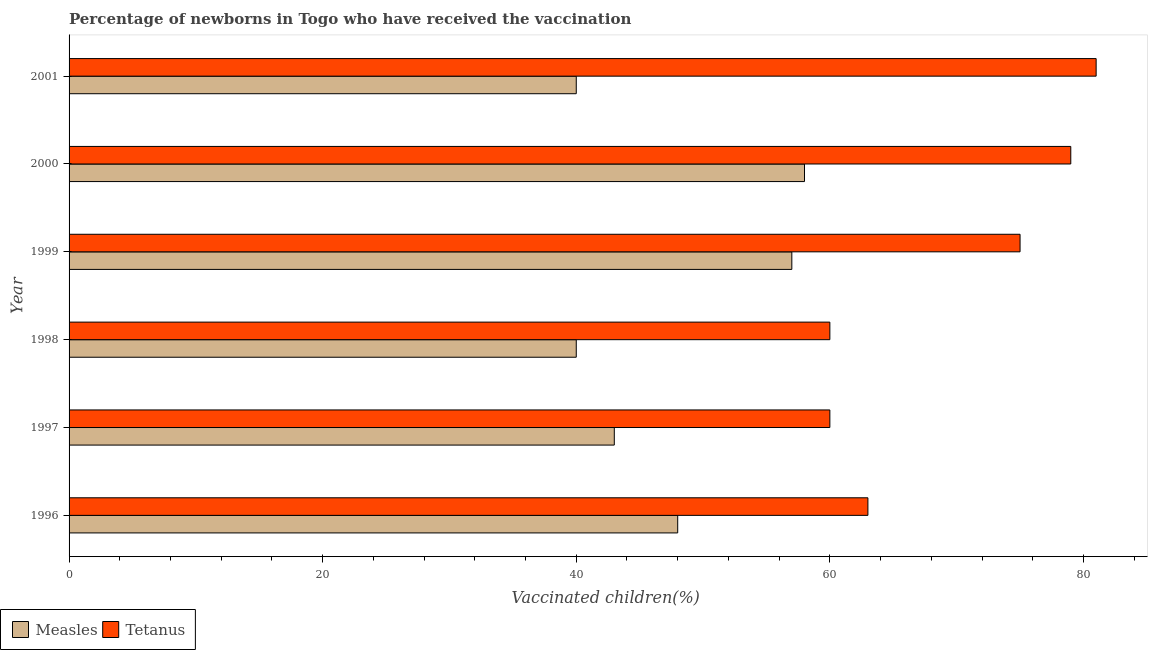How many different coloured bars are there?
Offer a terse response. 2. How many groups of bars are there?
Give a very brief answer. 6. Are the number of bars per tick equal to the number of legend labels?
Offer a very short reply. Yes. Are the number of bars on each tick of the Y-axis equal?
Ensure brevity in your answer.  Yes. How many bars are there on the 5th tick from the top?
Your answer should be very brief. 2. What is the label of the 5th group of bars from the top?
Your response must be concise. 1997. In how many cases, is the number of bars for a given year not equal to the number of legend labels?
Your response must be concise. 0. What is the percentage of newborns who received vaccination for tetanus in 1996?
Ensure brevity in your answer.  63. Across all years, what is the maximum percentage of newborns who received vaccination for tetanus?
Your response must be concise. 81. Across all years, what is the minimum percentage of newborns who received vaccination for tetanus?
Make the answer very short. 60. In which year was the percentage of newborns who received vaccination for measles maximum?
Your answer should be very brief. 2000. In which year was the percentage of newborns who received vaccination for tetanus minimum?
Your answer should be very brief. 1997. What is the total percentage of newborns who received vaccination for measles in the graph?
Your answer should be compact. 286. What is the difference between the percentage of newborns who received vaccination for tetanus in 2000 and that in 2001?
Offer a very short reply. -2. What is the difference between the percentage of newborns who received vaccination for measles in 2000 and the percentage of newborns who received vaccination for tetanus in 1996?
Your response must be concise. -5. What is the average percentage of newborns who received vaccination for tetanus per year?
Offer a terse response. 69.67. In the year 2000, what is the difference between the percentage of newborns who received vaccination for tetanus and percentage of newborns who received vaccination for measles?
Offer a very short reply. 21. In how many years, is the percentage of newborns who received vaccination for tetanus greater than 32 %?
Ensure brevity in your answer.  6. What is the ratio of the percentage of newborns who received vaccination for tetanus in 1997 to that in 1999?
Provide a succinct answer. 0.8. Is the percentage of newborns who received vaccination for measles in 1997 less than that in 2000?
Make the answer very short. Yes. Is the difference between the percentage of newborns who received vaccination for tetanus in 1997 and 1998 greater than the difference between the percentage of newborns who received vaccination for measles in 1997 and 1998?
Provide a succinct answer. No. What is the difference between the highest and the second highest percentage of newborns who received vaccination for tetanus?
Give a very brief answer. 2. What is the difference between the highest and the lowest percentage of newborns who received vaccination for measles?
Your answer should be very brief. 18. Is the sum of the percentage of newborns who received vaccination for measles in 1996 and 2001 greater than the maximum percentage of newborns who received vaccination for tetanus across all years?
Your answer should be compact. Yes. What does the 1st bar from the top in 2000 represents?
Your response must be concise. Tetanus. What does the 2nd bar from the bottom in 2001 represents?
Offer a very short reply. Tetanus. Are all the bars in the graph horizontal?
Make the answer very short. Yes. How many years are there in the graph?
Make the answer very short. 6. Does the graph contain any zero values?
Your answer should be very brief. No. Does the graph contain grids?
Make the answer very short. No. How are the legend labels stacked?
Provide a succinct answer. Horizontal. What is the title of the graph?
Keep it short and to the point. Percentage of newborns in Togo who have received the vaccination. Does "Methane" appear as one of the legend labels in the graph?
Keep it short and to the point. No. What is the label or title of the X-axis?
Offer a terse response. Vaccinated children(%)
. What is the label or title of the Y-axis?
Give a very brief answer. Year. What is the Vaccinated children(%)
 in Measles in 1999?
Make the answer very short. 57. What is the Vaccinated children(%)
 of Tetanus in 2000?
Provide a succinct answer. 79. What is the Vaccinated children(%)
 of Measles in 2001?
Ensure brevity in your answer.  40. What is the Vaccinated children(%)
 of Tetanus in 2001?
Your response must be concise. 81. Across all years, what is the maximum Vaccinated children(%)
 of Measles?
Your response must be concise. 58. Across all years, what is the minimum Vaccinated children(%)
 in Measles?
Offer a terse response. 40. Across all years, what is the minimum Vaccinated children(%)
 in Tetanus?
Your answer should be compact. 60. What is the total Vaccinated children(%)
 of Measles in the graph?
Offer a terse response. 286. What is the total Vaccinated children(%)
 in Tetanus in the graph?
Keep it short and to the point. 418. What is the difference between the Vaccinated children(%)
 of Measles in 1996 and that in 1998?
Offer a very short reply. 8. What is the difference between the Vaccinated children(%)
 in Tetanus in 1996 and that in 2001?
Your answer should be compact. -18. What is the difference between the Vaccinated children(%)
 in Measles in 1997 and that in 1999?
Provide a succinct answer. -14. What is the difference between the Vaccinated children(%)
 of Tetanus in 1997 and that in 1999?
Give a very brief answer. -15. What is the difference between the Vaccinated children(%)
 in Measles in 1997 and that in 2000?
Offer a terse response. -15. What is the difference between the Vaccinated children(%)
 in Tetanus in 1997 and that in 2000?
Ensure brevity in your answer.  -19. What is the difference between the Vaccinated children(%)
 of Tetanus in 1997 and that in 2001?
Provide a short and direct response. -21. What is the difference between the Vaccinated children(%)
 in Measles in 1998 and that in 1999?
Give a very brief answer. -17. What is the difference between the Vaccinated children(%)
 of Tetanus in 1998 and that in 1999?
Give a very brief answer. -15. What is the difference between the Vaccinated children(%)
 of Tetanus in 1998 and that in 2000?
Your response must be concise. -19. What is the difference between the Vaccinated children(%)
 of Tetanus in 1999 and that in 2000?
Keep it short and to the point. -4. What is the difference between the Vaccinated children(%)
 of Measles in 2000 and that in 2001?
Offer a very short reply. 18. What is the difference between the Vaccinated children(%)
 in Measles in 1996 and the Vaccinated children(%)
 in Tetanus in 1997?
Offer a very short reply. -12. What is the difference between the Vaccinated children(%)
 of Measles in 1996 and the Vaccinated children(%)
 of Tetanus in 1999?
Your answer should be compact. -27. What is the difference between the Vaccinated children(%)
 in Measles in 1996 and the Vaccinated children(%)
 in Tetanus in 2000?
Offer a terse response. -31. What is the difference between the Vaccinated children(%)
 in Measles in 1996 and the Vaccinated children(%)
 in Tetanus in 2001?
Your answer should be compact. -33. What is the difference between the Vaccinated children(%)
 in Measles in 1997 and the Vaccinated children(%)
 in Tetanus in 1998?
Offer a very short reply. -17. What is the difference between the Vaccinated children(%)
 in Measles in 1997 and the Vaccinated children(%)
 in Tetanus in 1999?
Keep it short and to the point. -32. What is the difference between the Vaccinated children(%)
 in Measles in 1997 and the Vaccinated children(%)
 in Tetanus in 2000?
Give a very brief answer. -36. What is the difference between the Vaccinated children(%)
 of Measles in 1997 and the Vaccinated children(%)
 of Tetanus in 2001?
Your answer should be very brief. -38. What is the difference between the Vaccinated children(%)
 of Measles in 1998 and the Vaccinated children(%)
 of Tetanus in 1999?
Your response must be concise. -35. What is the difference between the Vaccinated children(%)
 of Measles in 1998 and the Vaccinated children(%)
 of Tetanus in 2000?
Provide a succinct answer. -39. What is the difference between the Vaccinated children(%)
 in Measles in 1998 and the Vaccinated children(%)
 in Tetanus in 2001?
Make the answer very short. -41. What is the average Vaccinated children(%)
 of Measles per year?
Offer a very short reply. 47.67. What is the average Vaccinated children(%)
 in Tetanus per year?
Your response must be concise. 69.67. In the year 1996, what is the difference between the Vaccinated children(%)
 in Measles and Vaccinated children(%)
 in Tetanus?
Your answer should be compact. -15. In the year 1997, what is the difference between the Vaccinated children(%)
 of Measles and Vaccinated children(%)
 of Tetanus?
Give a very brief answer. -17. In the year 1999, what is the difference between the Vaccinated children(%)
 in Measles and Vaccinated children(%)
 in Tetanus?
Give a very brief answer. -18. In the year 2000, what is the difference between the Vaccinated children(%)
 of Measles and Vaccinated children(%)
 of Tetanus?
Offer a terse response. -21. In the year 2001, what is the difference between the Vaccinated children(%)
 in Measles and Vaccinated children(%)
 in Tetanus?
Your response must be concise. -41. What is the ratio of the Vaccinated children(%)
 of Measles in 1996 to that in 1997?
Provide a succinct answer. 1.12. What is the ratio of the Vaccinated children(%)
 in Measles in 1996 to that in 1998?
Keep it short and to the point. 1.2. What is the ratio of the Vaccinated children(%)
 in Tetanus in 1996 to that in 1998?
Offer a very short reply. 1.05. What is the ratio of the Vaccinated children(%)
 in Measles in 1996 to that in 1999?
Ensure brevity in your answer.  0.84. What is the ratio of the Vaccinated children(%)
 in Tetanus in 1996 to that in 1999?
Your response must be concise. 0.84. What is the ratio of the Vaccinated children(%)
 in Measles in 1996 to that in 2000?
Offer a terse response. 0.83. What is the ratio of the Vaccinated children(%)
 of Tetanus in 1996 to that in 2000?
Your answer should be very brief. 0.8. What is the ratio of the Vaccinated children(%)
 in Measles in 1997 to that in 1998?
Give a very brief answer. 1.07. What is the ratio of the Vaccinated children(%)
 in Measles in 1997 to that in 1999?
Offer a very short reply. 0.75. What is the ratio of the Vaccinated children(%)
 in Tetanus in 1997 to that in 1999?
Your response must be concise. 0.8. What is the ratio of the Vaccinated children(%)
 in Measles in 1997 to that in 2000?
Offer a very short reply. 0.74. What is the ratio of the Vaccinated children(%)
 of Tetanus in 1997 to that in 2000?
Offer a very short reply. 0.76. What is the ratio of the Vaccinated children(%)
 of Measles in 1997 to that in 2001?
Make the answer very short. 1.07. What is the ratio of the Vaccinated children(%)
 in Tetanus in 1997 to that in 2001?
Your answer should be compact. 0.74. What is the ratio of the Vaccinated children(%)
 in Measles in 1998 to that in 1999?
Your response must be concise. 0.7. What is the ratio of the Vaccinated children(%)
 of Measles in 1998 to that in 2000?
Your answer should be very brief. 0.69. What is the ratio of the Vaccinated children(%)
 of Tetanus in 1998 to that in 2000?
Give a very brief answer. 0.76. What is the ratio of the Vaccinated children(%)
 of Tetanus in 1998 to that in 2001?
Make the answer very short. 0.74. What is the ratio of the Vaccinated children(%)
 in Measles in 1999 to that in 2000?
Provide a short and direct response. 0.98. What is the ratio of the Vaccinated children(%)
 in Tetanus in 1999 to that in 2000?
Your answer should be very brief. 0.95. What is the ratio of the Vaccinated children(%)
 in Measles in 1999 to that in 2001?
Make the answer very short. 1.43. What is the ratio of the Vaccinated children(%)
 of Tetanus in 1999 to that in 2001?
Offer a very short reply. 0.93. What is the ratio of the Vaccinated children(%)
 in Measles in 2000 to that in 2001?
Make the answer very short. 1.45. What is the ratio of the Vaccinated children(%)
 in Tetanus in 2000 to that in 2001?
Keep it short and to the point. 0.98. What is the difference between the highest and the second highest Vaccinated children(%)
 in Measles?
Make the answer very short. 1. What is the difference between the highest and the second highest Vaccinated children(%)
 of Tetanus?
Offer a very short reply. 2. 